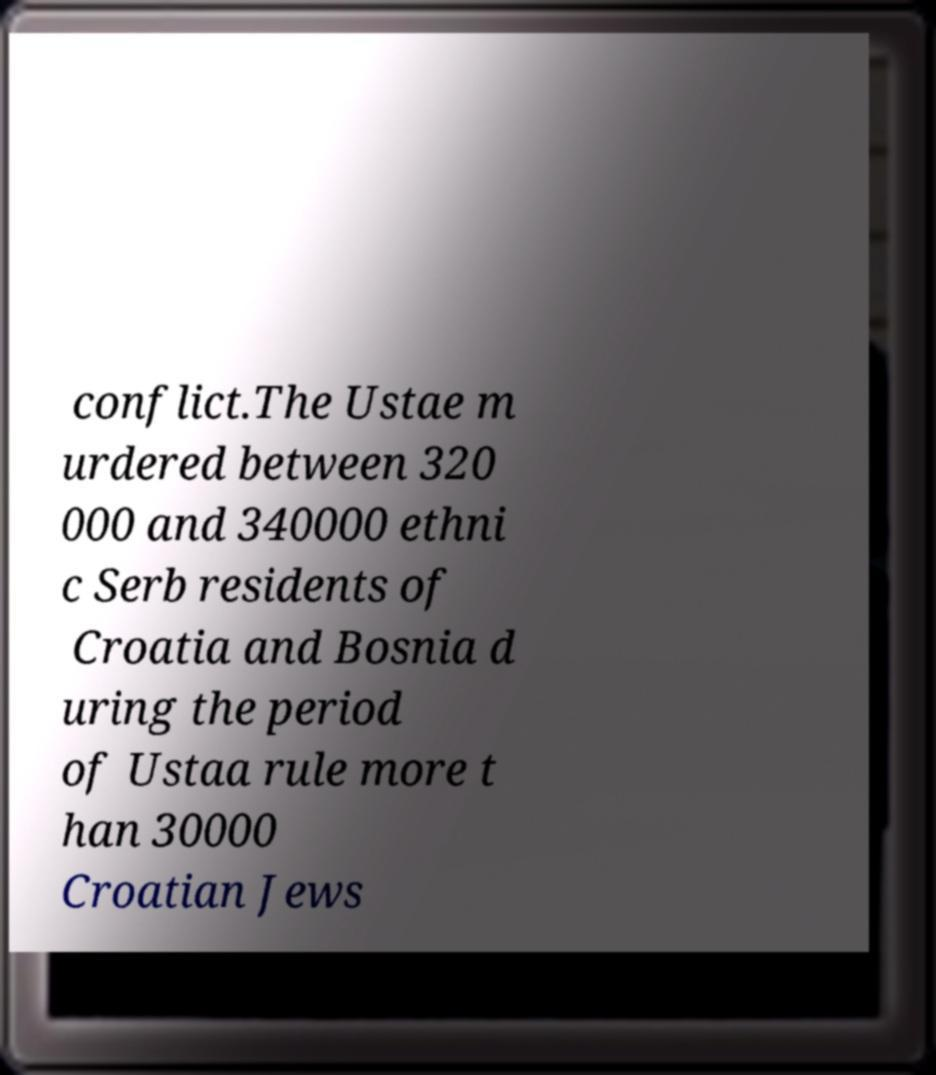What messages or text are displayed in this image? I need them in a readable, typed format. conflict.The Ustae m urdered between 320 000 and 340000 ethni c Serb residents of Croatia and Bosnia d uring the period of Ustaa rule more t han 30000 Croatian Jews 